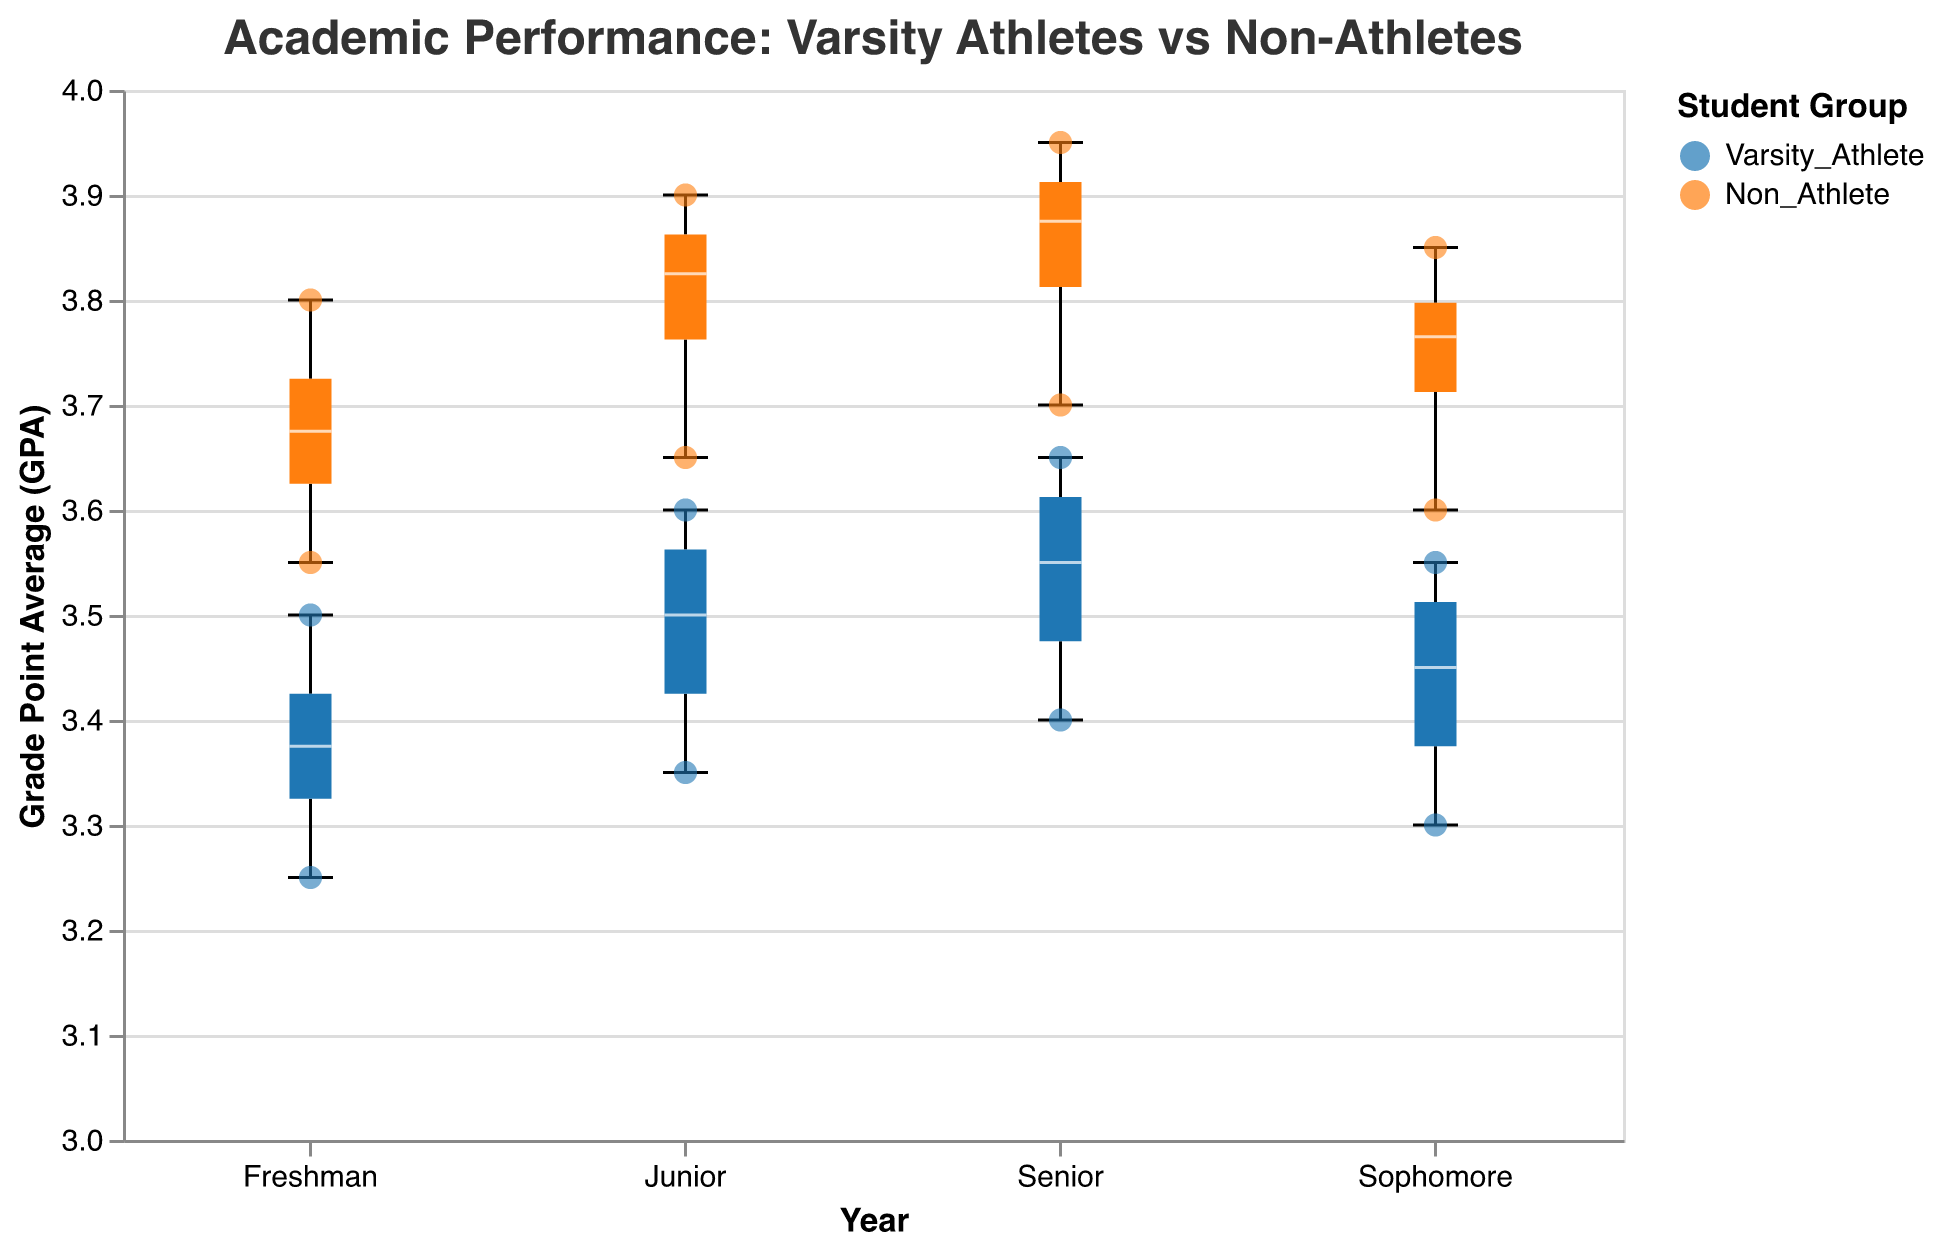How does the GPA of non-athletes compare to varsity athletes in their senior year? To answer this question, observe the median values in the box plots for both groups in the senior year. The GPA values for non-athletes are higher compared to varsity athletes, as non-athletes have a median hovering around 3.875, while for varsity athletes, it's about 3.525.
Answer: Non-athletes have higher median GPAs What is the range (minimum and maximum GPA) for varsity athletes in their junior year? Check the box plot whiskers for the junior year in the varsity athlete group. The minimum GPA is 3.35 and the maximum GPA is 3.60 for varsity athletes.
Answer: 3.35 to 3.60 Who has the highest GPA among freshmen? Examine the scatter points for the freshman year. Gregory Green among non-athletes has the highest GPA of 3.80.
Answer: Gregory Green Which group shows a greater increase in median GPA from freshman to senior year? Compare the rise in the median lines in the box plots from freshman to senior year for both groups. Non-athletes show a greater increase because the median rises from around 3.65 to 3.875, while varsity athletes rise from 3.325 to about 3.525.
Answer: Non-athletes Are there any outliers in the GPAs of varsity athletes over the four years? Look at the scatter points outside the whiskers of the box plots for varsity athletes over the years. There are no outliers since all points fit within the whiskers.
Answer: No Which year shows the smallest interquartile range (IQR) for non-athletes? Evaluate the width of the boxes for non-athletes over the years. The junior year has the smallest IQR since the box is the narrowest, meaning the spread between the first and third quartiles is smallest.
Answer: Junior year How do the GPA trends for varsity athletes and non-athletes compare over the four years? Observe the median lines through the box plots for both groups. GPAs for both groups increase, but non-athletes illustrate a more consistent and significant rise compared to varsity athletes.
Answer: Non-athletes show a more significant increase What is the median GPA for non-athletes in their sophomore year? Check the middle line of the box plot for non-athletes in their sophomore year. The median GPA is 3.77.
Answer: 3.77 What does the shape of the box plot indicate about the distribution of GPAs for varsity athletes in their freshman year? The shape, including the length of the whiskers and box, suggests that the GPAs are fairly tightly clustered with no extreme values or wide distribution since the box is not excessively elongated.
Answer: Fairly tightly clustered distribution How does the spread or variability in GPAs compare between the two groups in sophomore year? Compare the length of boxes and whiskers for both groups in the sophomore year. Non-athletes have a wider distribution with higher variability, as indicated by a broader range in the box and whiskers, compared to varsity athletes.
Answer: Non-athletes have higher variability 